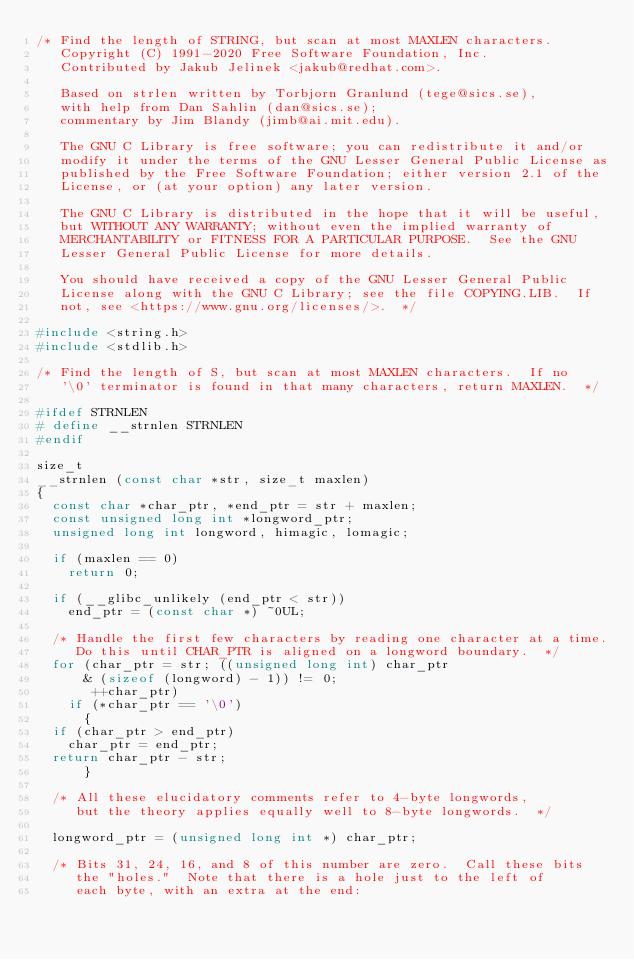<code> <loc_0><loc_0><loc_500><loc_500><_C_>/* Find the length of STRING, but scan at most MAXLEN characters.
   Copyright (C) 1991-2020 Free Software Foundation, Inc.
   Contributed by Jakub Jelinek <jakub@redhat.com>.

   Based on strlen written by Torbjorn Granlund (tege@sics.se),
   with help from Dan Sahlin (dan@sics.se);
   commentary by Jim Blandy (jimb@ai.mit.edu).

   The GNU C Library is free software; you can redistribute it and/or
   modify it under the terms of the GNU Lesser General Public License as
   published by the Free Software Foundation; either version 2.1 of the
   License, or (at your option) any later version.

   The GNU C Library is distributed in the hope that it will be useful,
   but WITHOUT ANY WARRANTY; without even the implied warranty of
   MERCHANTABILITY or FITNESS FOR A PARTICULAR PURPOSE.  See the GNU
   Lesser General Public License for more details.

   You should have received a copy of the GNU Lesser General Public
   License along with the GNU C Library; see the file COPYING.LIB.  If
   not, see <https://www.gnu.org/licenses/>.  */

#include <string.h>
#include <stdlib.h>

/* Find the length of S, but scan at most MAXLEN characters.  If no
   '\0' terminator is found in that many characters, return MAXLEN.  */

#ifdef STRNLEN
# define __strnlen STRNLEN
#endif

size_t
__strnlen (const char *str, size_t maxlen)
{
  const char *char_ptr, *end_ptr = str + maxlen;
  const unsigned long int *longword_ptr;
  unsigned long int longword, himagic, lomagic;

  if (maxlen == 0)
    return 0;

  if (__glibc_unlikely (end_ptr < str))
    end_ptr = (const char *) ~0UL;

  /* Handle the first few characters by reading one character at a time.
     Do this until CHAR_PTR is aligned on a longword boundary.  */
  for (char_ptr = str; ((unsigned long int) char_ptr
			& (sizeof (longword) - 1)) != 0;
       ++char_ptr)
    if (*char_ptr == '\0')
      {
	if (char_ptr > end_ptr)
	  char_ptr = end_ptr;
	return char_ptr - str;
      }

  /* All these elucidatory comments refer to 4-byte longwords,
     but the theory applies equally well to 8-byte longwords.  */

  longword_ptr = (unsigned long int *) char_ptr;

  /* Bits 31, 24, 16, and 8 of this number are zero.  Call these bits
     the "holes."  Note that there is a hole just to the left of
     each byte, with an extra at the end:
</code> 